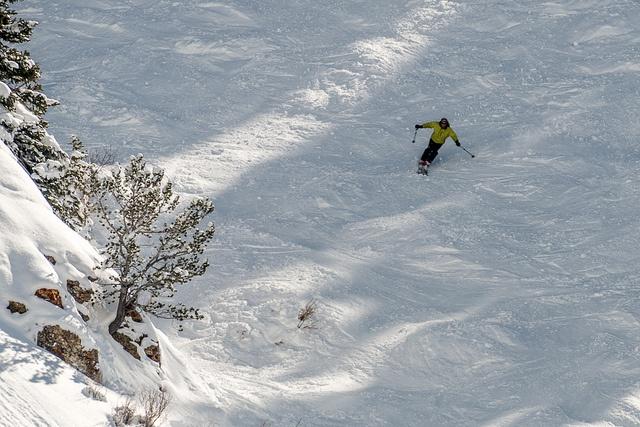Describe the objects in this image and their specific colors. I can see people in darkgray, black, olive, gray, and maroon tones and skis in darkgray, gray, and black tones in this image. 